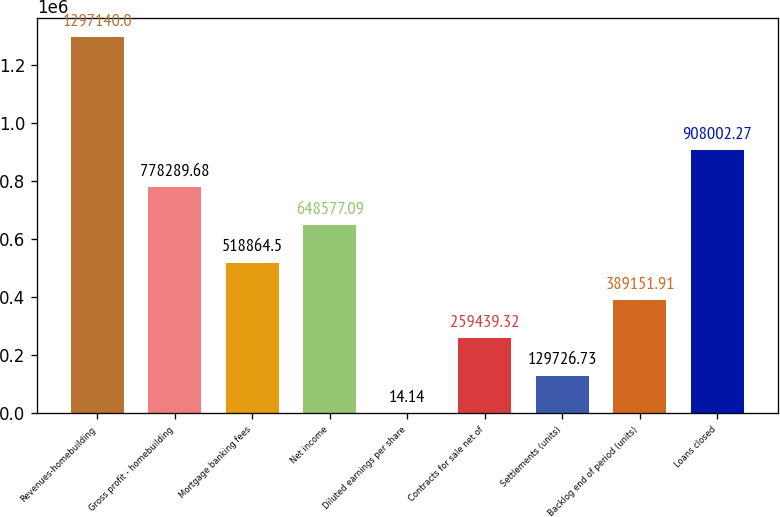Convert chart. <chart><loc_0><loc_0><loc_500><loc_500><bar_chart><fcel>Revenues-homebuilding<fcel>Gross profit - homebuilding<fcel>Mortgage banking fees<fcel>Net income<fcel>Diluted earnings per share<fcel>Contracts for sale net of<fcel>Settlements (units)<fcel>Backlog end of period (units)<fcel>Loans closed<nl><fcel>1.29714e+06<fcel>778290<fcel>518864<fcel>648577<fcel>14.14<fcel>259439<fcel>129727<fcel>389152<fcel>908002<nl></chart> 